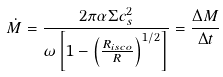<formula> <loc_0><loc_0><loc_500><loc_500>\dot { M } = \frac { 2 \pi \alpha \Sigma c _ { s } ^ { 2 } } { \omega \left [ 1 - \left ( \frac { R _ { i s c o } } { R } \right ) ^ { 1 / 2 } \right ] } = \frac { \Delta M } { \Delta t }</formula> 